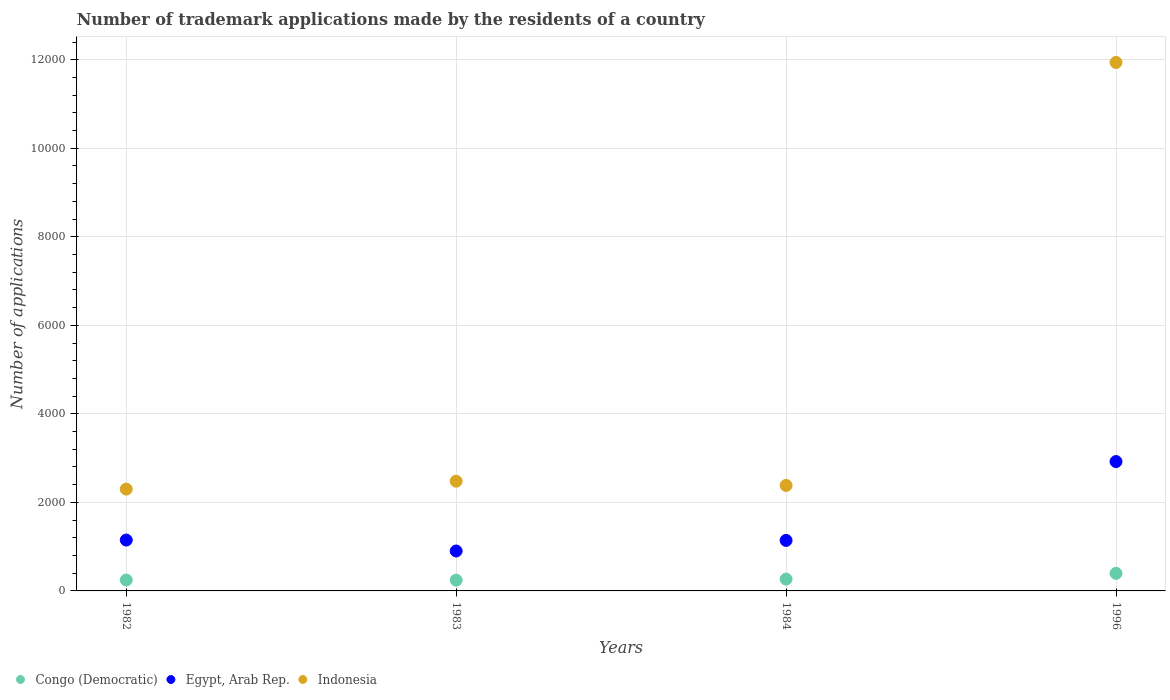What is the number of trademark applications made by the residents in Congo (Democratic) in 1983?
Provide a short and direct response. 243. Across all years, what is the maximum number of trademark applications made by the residents in Indonesia?
Give a very brief answer. 1.19e+04. Across all years, what is the minimum number of trademark applications made by the residents in Congo (Democratic)?
Offer a terse response. 243. In which year was the number of trademark applications made by the residents in Indonesia minimum?
Offer a very short reply. 1982. What is the total number of trademark applications made by the residents in Congo (Democratic) in the graph?
Your answer should be very brief. 1153. What is the difference between the number of trademark applications made by the residents in Indonesia in 1982 and that in 1983?
Provide a short and direct response. -179. What is the difference between the number of trademark applications made by the residents in Indonesia in 1983 and the number of trademark applications made by the residents in Egypt, Arab Rep. in 1996?
Make the answer very short. -443. What is the average number of trademark applications made by the residents in Egypt, Arab Rep. per year?
Your response must be concise. 1528.5. In the year 1984, what is the difference between the number of trademark applications made by the residents in Indonesia and number of trademark applications made by the residents in Congo (Democratic)?
Ensure brevity in your answer.  2116. What is the ratio of the number of trademark applications made by the residents in Congo (Democratic) in 1982 to that in 1996?
Provide a short and direct response. 0.62. Is the number of trademark applications made by the residents in Egypt, Arab Rep. in 1982 less than that in 1984?
Your answer should be compact. No. What is the difference between the highest and the second highest number of trademark applications made by the residents in Congo (Democratic)?
Provide a succinct answer. 130. What is the difference between the highest and the lowest number of trademark applications made by the residents in Congo (Democratic)?
Your answer should be very brief. 154. In how many years, is the number of trademark applications made by the residents in Indonesia greater than the average number of trademark applications made by the residents in Indonesia taken over all years?
Make the answer very short. 1. Is the sum of the number of trademark applications made by the residents in Indonesia in 1984 and 1996 greater than the maximum number of trademark applications made by the residents in Egypt, Arab Rep. across all years?
Offer a terse response. Yes. Is it the case that in every year, the sum of the number of trademark applications made by the residents in Congo (Democratic) and number of trademark applications made by the residents in Indonesia  is greater than the number of trademark applications made by the residents in Egypt, Arab Rep.?
Give a very brief answer. Yes. Does the number of trademark applications made by the residents in Indonesia monotonically increase over the years?
Offer a terse response. No. Is the number of trademark applications made by the residents in Congo (Democratic) strictly greater than the number of trademark applications made by the residents in Egypt, Arab Rep. over the years?
Make the answer very short. No. Is the number of trademark applications made by the residents in Egypt, Arab Rep. strictly less than the number of trademark applications made by the residents in Congo (Democratic) over the years?
Your answer should be very brief. No. How many years are there in the graph?
Your response must be concise. 4. What is the difference between two consecutive major ticks on the Y-axis?
Keep it short and to the point. 2000. Are the values on the major ticks of Y-axis written in scientific E-notation?
Make the answer very short. No. Does the graph contain any zero values?
Offer a terse response. No. Does the graph contain grids?
Offer a terse response. Yes. Where does the legend appear in the graph?
Offer a very short reply. Bottom left. How many legend labels are there?
Your response must be concise. 3. How are the legend labels stacked?
Give a very brief answer. Horizontal. What is the title of the graph?
Provide a short and direct response. Number of trademark applications made by the residents of a country. What is the label or title of the X-axis?
Offer a terse response. Years. What is the label or title of the Y-axis?
Provide a succinct answer. Number of applications. What is the Number of applications in Congo (Democratic) in 1982?
Keep it short and to the point. 246. What is the Number of applications of Egypt, Arab Rep. in 1982?
Provide a short and direct response. 1149. What is the Number of applications in Indonesia in 1982?
Give a very brief answer. 2300. What is the Number of applications in Congo (Democratic) in 1983?
Offer a terse response. 243. What is the Number of applications in Egypt, Arab Rep. in 1983?
Ensure brevity in your answer.  902. What is the Number of applications in Indonesia in 1983?
Give a very brief answer. 2479. What is the Number of applications of Congo (Democratic) in 1984?
Your response must be concise. 267. What is the Number of applications of Egypt, Arab Rep. in 1984?
Give a very brief answer. 1141. What is the Number of applications in Indonesia in 1984?
Your response must be concise. 2383. What is the Number of applications in Congo (Democratic) in 1996?
Keep it short and to the point. 397. What is the Number of applications of Egypt, Arab Rep. in 1996?
Offer a very short reply. 2922. What is the Number of applications in Indonesia in 1996?
Your answer should be very brief. 1.19e+04. Across all years, what is the maximum Number of applications of Congo (Democratic)?
Make the answer very short. 397. Across all years, what is the maximum Number of applications of Egypt, Arab Rep.?
Keep it short and to the point. 2922. Across all years, what is the maximum Number of applications in Indonesia?
Offer a very short reply. 1.19e+04. Across all years, what is the minimum Number of applications in Congo (Democratic)?
Provide a succinct answer. 243. Across all years, what is the minimum Number of applications in Egypt, Arab Rep.?
Make the answer very short. 902. Across all years, what is the minimum Number of applications of Indonesia?
Ensure brevity in your answer.  2300. What is the total Number of applications of Congo (Democratic) in the graph?
Provide a succinct answer. 1153. What is the total Number of applications in Egypt, Arab Rep. in the graph?
Your answer should be very brief. 6114. What is the total Number of applications in Indonesia in the graph?
Provide a succinct answer. 1.91e+04. What is the difference between the Number of applications in Egypt, Arab Rep. in 1982 and that in 1983?
Your answer should be very brief. 247. What is the difference between the Number of applications of Indonesia in 1982 and that in 1983?
Give a very brief answer. -179. What is the difference between the Number of applications of Congo (Democratic) in 1982 and that in 1984?
Ensure brevity in your answer.  -21. What is the difference between the Number of applications of Egypt, Arab Rep. in 1982 and that in 1984?
Provide a succinct answer. 8. What is the difference between the Number of applications of Indonesia in 1982 and that in 1984?
Provide a short and direct response. -83. What is the difference between the Number of applications of Congo (Democratic) in 1982 and that in 1996?
Provide a short and direct response. -151. What is the difference between the Number of applications in Egypt, Arab Rep. in 1982 and that in 1996?
Keep it short and to the point. -1773. What is the difference between the Number of applications of Indonesia in 1982 and that in 1996?
Give a very brief answer. -9638. What is the difference between the Number of applications in Congo (Democratic) in 1983 and that in 1984?
Ensure brevity in your answer.  -24. What is the difference between the Number of applications in Egypt, Arab Rep. in 1983 and that in 1984?
Make the answer very short. -239. What is the difference between the Number of applications in Indonesia in 1983 and that in 1984?
Keep it short and to the point. 96. What is the difference between the Number of applications of Congo (Democratic) in 1983 and that in 1996?
Keep it short and to the point. -154. What is the difference between the Number of applications in Egypt, Arab Rep. in 1983 and that in 1996?
Ensure brevity in your answer.  -2020. What is the difference between the Number of applications in Indonesia in 1983 and that in 1996?
Your answer should be very brief. -9459. What is the difference between the Number of applications of Congo (Democratic) in 1984 and that in 1996?
Provide a succinct answer. -130. What is the difference between the Number of applications of Egypt, Arab Rep. in 1984 and that in 1996?
Give a very brief answer. -1781. What is the difference between the Number of applications in Indonesia in 1984 and that in 1996?
Provide a short and direct response. -9555. What is the difference between the Number of applications of Congo (Democratic) in 1982 and the Number of applications of Egypt, Arab Rep. in 1983?
Ensure brevity in your answer.  -656. What is the difference between the Number of applications of Congo (Democratic) in 1982 and the Number of applications of Indonesia in 1983?
Your answer should be compact. -2233. What is the difference between the Number of applications of Egypt, Arab Rep. in 1982 and the Number of applications of Indonesia in 1983?
Keep it short and to the point. -1330. What is the difference between the Number of applications of Congo (Democratic) in 1982 and the Number of applications of Egypt, Arab Rep. in 1984?
Ensure brevity in your answer.  -895. What is the difference between the Number of applications in Congo (Democratic) in 1982 and the Number of applications in Indonesia in 1984?
Ensure brevity in your answer.  -2137. What is the difference between the Number of applications in Egypt, Arab Rep. in 1982 and the Number of applications in Indonesia in 1984?
Your answer should be very brief. -1234. What is the difference between the Number of applications in Congo (Democratic) in 1982 and the Number of applications in Egypt, Arab Rep. in 1996?
Your response must be concise. -2676. What is the difference between the Number of applications of Congo (Democratic) in 1982 and the Number of applications of Indonesia in 1996?
Your answer should be very brief. -1.17e+04. What is the difference between the Number of applications in Egypt, Arab Rep. in 1982 and the Number of applications in Indonesia in 1996?
Offer a terse response. -1.08e+04. What is the difference between the Number of applications of Congo (Democratic) in 1983 and the Number of applications of Egypt, Arab Rep. in 1984?
Offer a terse response. -898. What is the difference between the Number of applications in Congo (Democratic) in 1983 and the Number of applications in Indonesia in 1984?
Provide a succinct answer. -2140. What is the difference between the Number of applications in Egypt, Arab Rep. in 1983 and the Number of applications in Indonesia in 1984?
Your response must be concise. -1481. What is the difference between the Number of applications of Congo (Democratic) in 1983 and the Number of applications of Egypt, Arab Rep. in 1996?
Your answer should be very brief. -2679. What is the difference between the Number of applications in Congo (Democratic) in 1983 and the Number of applications in Indonesia in 1996?
Provide a short and direct response. -1.17e+04. What is the difference between the Number of applications of Egypt, Arab Rep. in 1983 and the Number of applications of Indonesia in 1996?
Provide a short and direct response. -1.10e+04. What is the difference between the Number of applications in Congo (Democratic) in 1984 and the Number of applications in Egypt, Arab Rep. in 1996?
Keep it short and to the point. -2655. What is the difference between the Number of applications of Congo (Democratic) in 1984 and the Number of applications of Indonesia in 1996?
Give a very brief answer. -1.17e+04. What is the difference between the Number of applications in Egypt, Arab Rep. in 1984 and the Number of applications in Indonesia in 1996?
Keep it short and to the point. -1.08e+04. What is the average Number of applications in Congo (Democratic) per year?
Ensure brevity in your answer.  288.25. What is the average Number of applications in Egypt, Arab Rep. per year?
Your answer should be compact. 1528.5. What is the average Number of applications of Indonesia per year?
Your answer should be compact. 4775. In the year 1982, what is the difference between the Number of applications in Congo (Democratic) and Number of applications in Egypt, Arab Rep.?
Make the answer very short. -903. In the year 1982, what is the difference between the Number of applications of Congo (Democratic) and Number of applications of Indonesia?
Offer a very short reply. -2054. In the year 1982, what is the difference between the Number of applications of Egypt, Arab Rep. and Number of applications of Indonesia?
Provide a succinct answer. -1151. In the year 1983, what is the difference between the Number of applications of Congo (Democratic) and Number of applications of Egypt, Arab Rep.?
Keep it short and to the point. -659. In the year 1983, what is the difference between the Number of applications of Congo (Democratic) and Number of applications of Indonesia?
Ensure brevity in your answer.  -2236. In the year 1983, what is the difference between the Number of applications of Egypt, Arab Rep. and Number of applications of Indonesia?
Offer a terse response. -1577. In the year 1984, what is the difference between the Number of applications in Congo (Democratic) and Number of applications in Egypt, Arab Rep.?
Your response must be concise. -874. In the year 1984, what is the difference between the Number of applications in Congo (Democratic) and Number of applications in Indonesia?
Make the answer very short. -2116. In the year 1984, what is the difference between the Number of applications of Egypt, Arab Rep. and Number of applications of Indonesia?
Your answer should be compact. -1242. In the year 1996, what is the difference between the Number of applications of Congo (Democratic) and Number of applications of Egypt, Arab Rep.?
Give a very brief answer. -2525. In the year 1996, what is the difference between the Number of applications of Congo (Democratic) and Number of applications of Indonesia?
Provide a succinct answer. -1.15e+04. In the year 1996, what is the difference between the Number of applications of Egypt, Arab Rep. and Number of applications of Indonesia?
Give a very brief answer. -9016. What is the ratio of the Number of applications of Congo (Democratic) in 1982 to that in 1983?
Offer a terse response. 1.01. What is the ratio of the Number of applications in Egypt, Arab Rep. in 1982 to that in 1983?
Ensure brevity in your answer.  1.27. What is the ratio of the Number of applications in Indonesia in 1982 to that in 1983?
Provide a succinct answer. 0.93. What is the ratio of the Number of applications of Congo (Democratic) in 1982 to that in 1984?
Make the answer very short. 0.92. What is the ratio of the Number of applications of Egypt, Arab Rep. in 1982 to that in 1984?
Make the answer very short. 1.01. What is the ratio of the Number of applications in Indonesia in 1982 to that in 1984?
Give a very brief answer. 0.97. What is the ratio of the Number of applications of Congo (Democratic) in 1982 to that in 1996?
Ensure brevity in your answer.  0.62. What is the ratio of the Number of applications of Egypt, Arab Rep. in 1982 to that in 1996?
Your response must be concise. 0.39. What is the ratio of the Number of applications of Indonesia in 1982 to that in 1996?
Give a very brief answer. 0.19. What is the ratio of the Number of applications of Congo (Democratic) in 1983 to that in 1984?
Your answer should be very brief. 0.91. What is the ratio of the Number of applications in Egypt, Arab Rep. in 1983 to that in 1984?
Offer a very short reply. 0.79. What is the ratio of the Number of applications of Indonesia in 1983 to that in 1984?
Make the answer very short. 1.04. What is the ratio of the Number of applications of Congo (Democratic) in 1983 to that in 1996?
Give a very brief answer. 0.61. What is the ratio of the Number of applications in Egypt, Arab Rep. in 1983 to that in 1996?
Your answer should be compact. 0.31. What is the ratio of the Number of applications in Indonesia in 1983 to that in 1996?
Ensure brevity in your answer.  0.21. What is the ratio of the Number of applications of Congo (Democratic) in 1984 to that in 1996?
Ensure brevity in your answer.  0.67. What is the ratio of the Number of applications in Egypt, Arab Rep. in 1984 to that in 1996?
Provide a succinct answer. 0.39. What is the ratio of the Number of applications of Indonesia in 1984 to that in 1996?
Your answer should be compact. 0.2. What is the difference between the highest and the second highest Number of applications in Congo (Democratic)?
Offer a terse response. 130. What is the difference between the highest and the second highest Number of applications of Egypt, Arab Rep.?
Provide a short and direct response. 1773. What is the difference between the highest and the second highest Number of applications of Indonesia?
Your response must be concise. 9459. What is the difference between the highest and the lowest Number of applications of Congo (Democratic)?
Your answer should be very brief. 154. What is the difference between the highest and the lowest Number of applications of Egypt, Arab Rep.?
Your response must be concise. 2020. What is the difference between the highest and the lowest Number of applications of Indonesia?
Make the answer very short. 9638. 